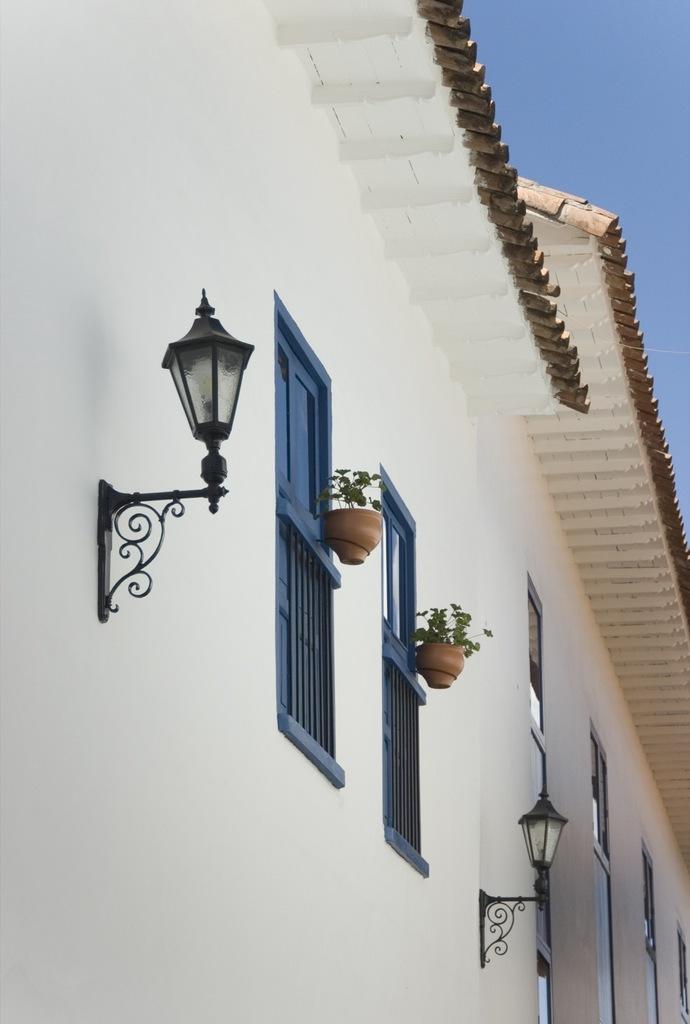Can you describe this image briefly? In this image we can see a building with a roof, street lamps, some plants in the pots, windows and the railing. We can also see the sky which looks cloudy. 